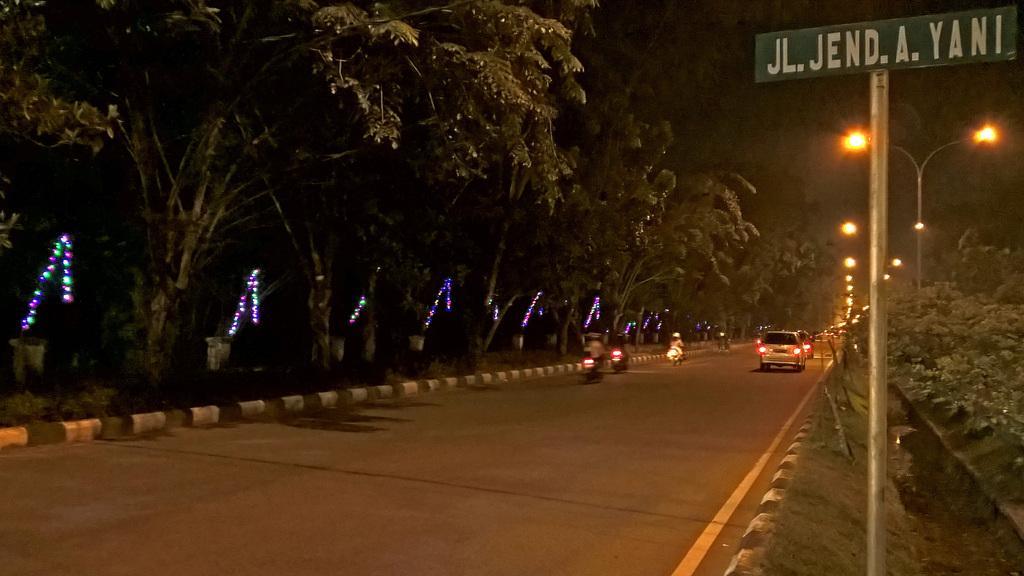Could you give a brief overview of what you see in this image? In this image, we can see vehicles on the road and in the background, there are trees, lights, poles and we can see a board. 